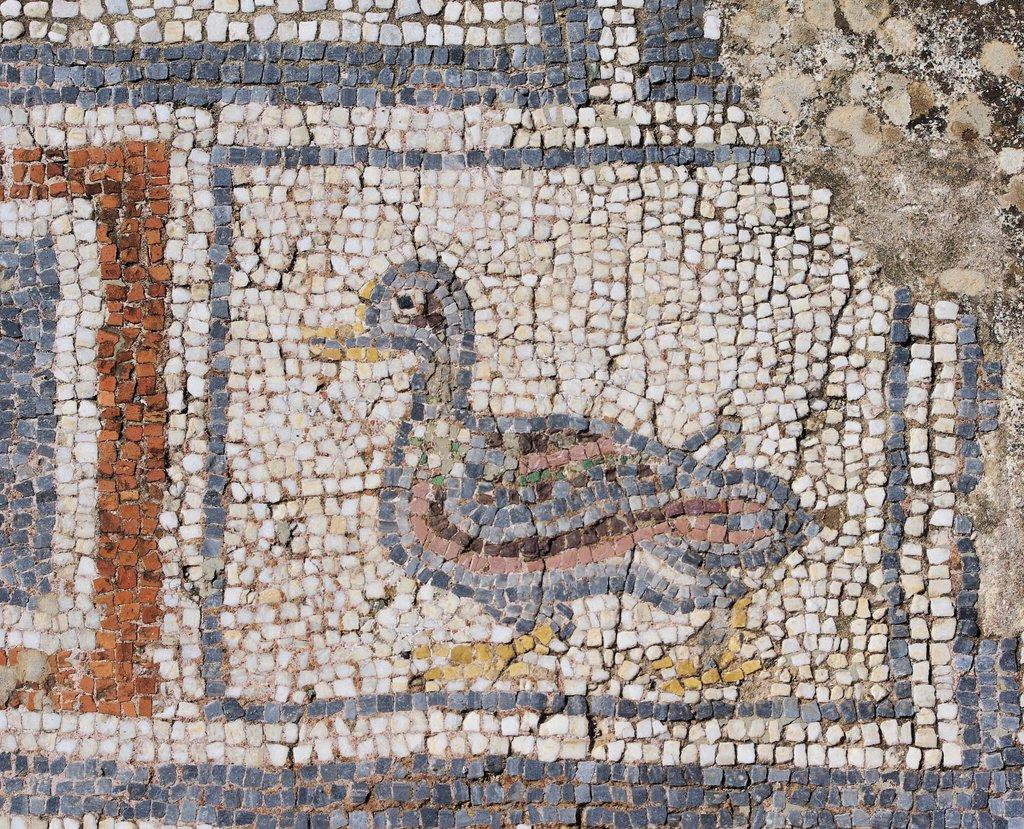What type of material is used to build the wall in the image? The wall in the image is made of stones. Can you describe the appearance of the stones on the wall? The stones on the wall have a rough texture and are arranged in a pattern. What might the wall be used for in the image? The wall could be used for decoration, support, or as a boundary. Can you hear the thunder in the image? There is no mention of thunder or any sound in the image, so it cannot be heard. 